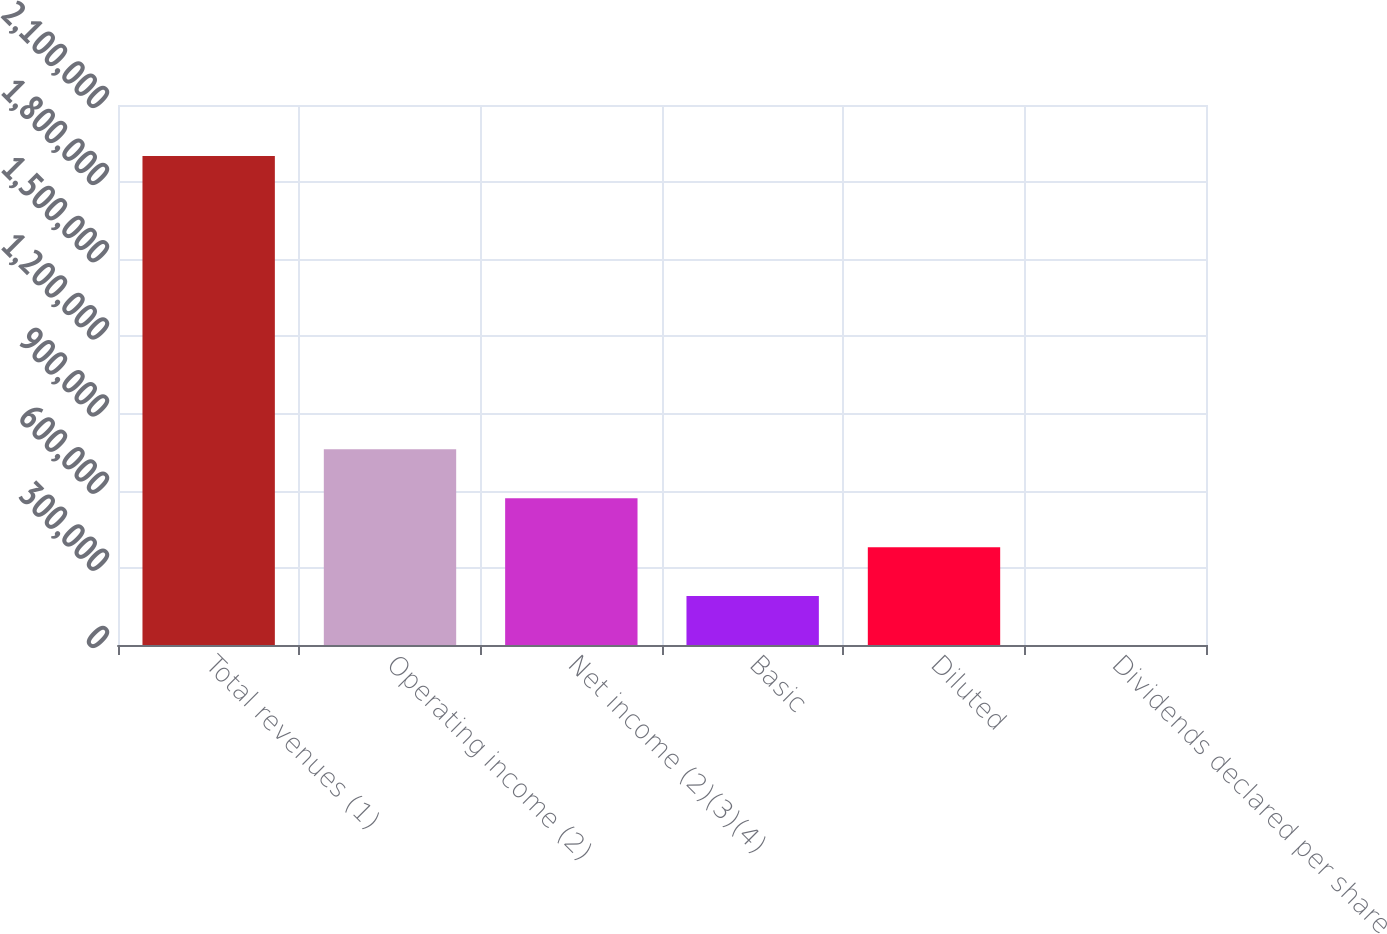Convert chart. <chart><loc_0><loc_0><loc_500><loc_500><bar_chart><fcel>Total revenues (1)<fcel>Operating income (2)<fcel>Net income (2)(3)(4)<fcel>Basic<fcel>Diluted<fcel>Dividends declared per share<nl><fcel>1.90205e+06<fcel>760821<fcel>570616<fcel>190206<fcel>380411<fcel>0.38<nl></chart> 